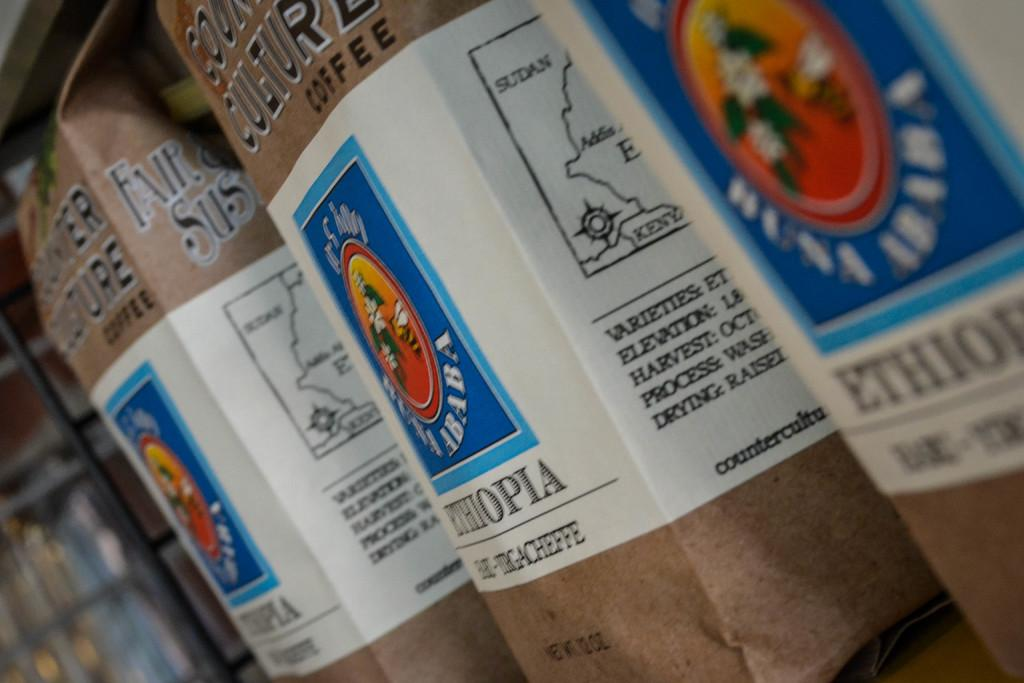<image>
Describe the image concisely. Bags of fair trade coffee from Ethiopia are lined up. 